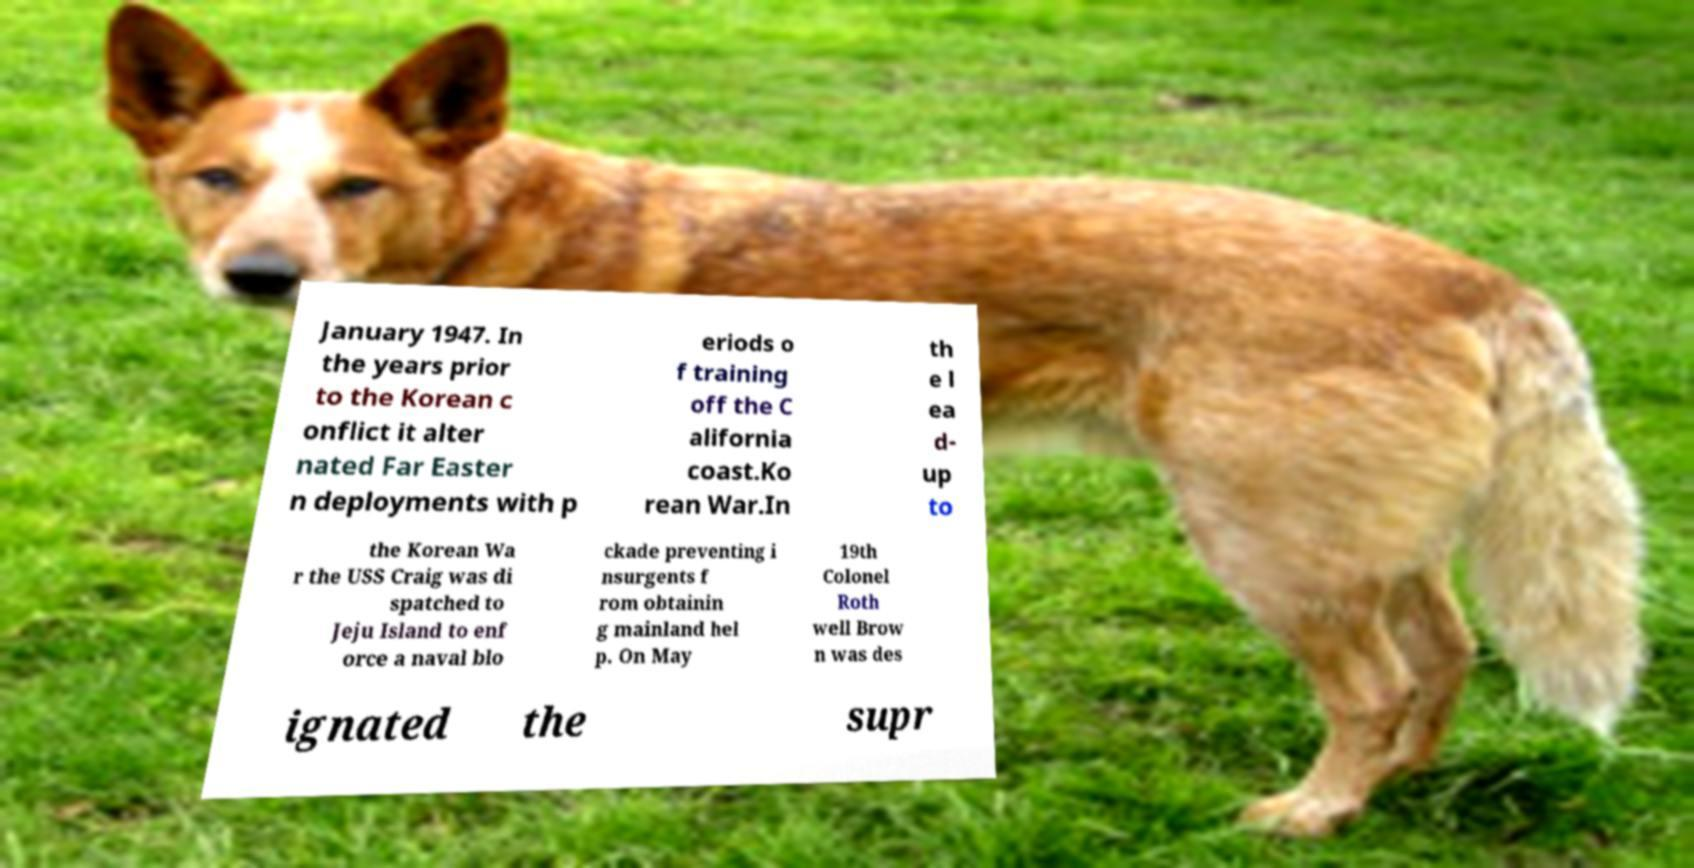What messages or text are displayed in this image? I need them in a readable, typed format. January 1947. In the years prior to the Korean c onflict it alter nated Far Easter n deployments with p eriods o f training off the C alifornia coast.Ko rean War.In th e l ea d- up to the Korean Wa r the USS Craig was di spatched to Jeju Island to enf orce a naval blo ckade preventing i nsurgents f rom obtainin g mainland hel p. On May 19th Colonel Roth well Brow n was des ignated the supr 